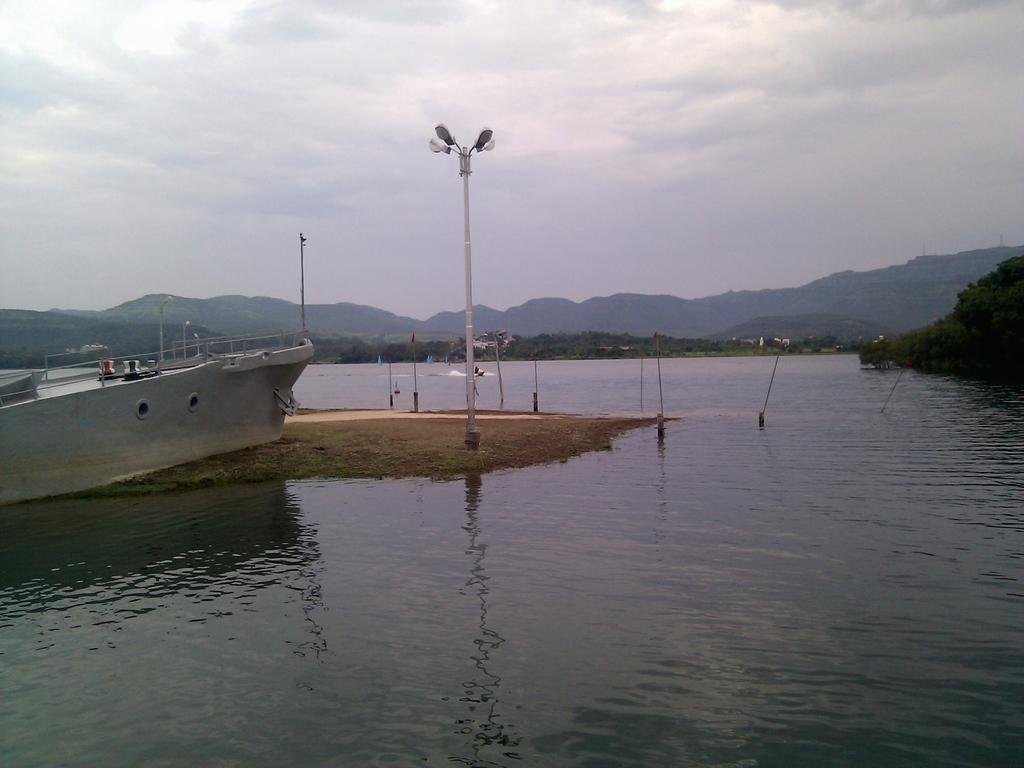What type of natural feature can be seen in the image? There is a river in the image. What geographical feature is visible in the background? There are mountains in the image. What type of vegetation is present in the image? There are trees and plants in the image. What man-made object is in the image? There is a boat in the image. What structure with lights can be seen in the image? There is a pole with lights in the image. How many men are plotting to steal the apples in the image? There are no men or apples present in the image. What type of fruit is growing on the trees in the image? The image does not show any fruit growing on the trees; only trees and plants are visible. 